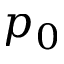Convert formula to latex. <formula><loc_0><loc_0><loc_500><loc_500>p _ { 0 }</formula> 